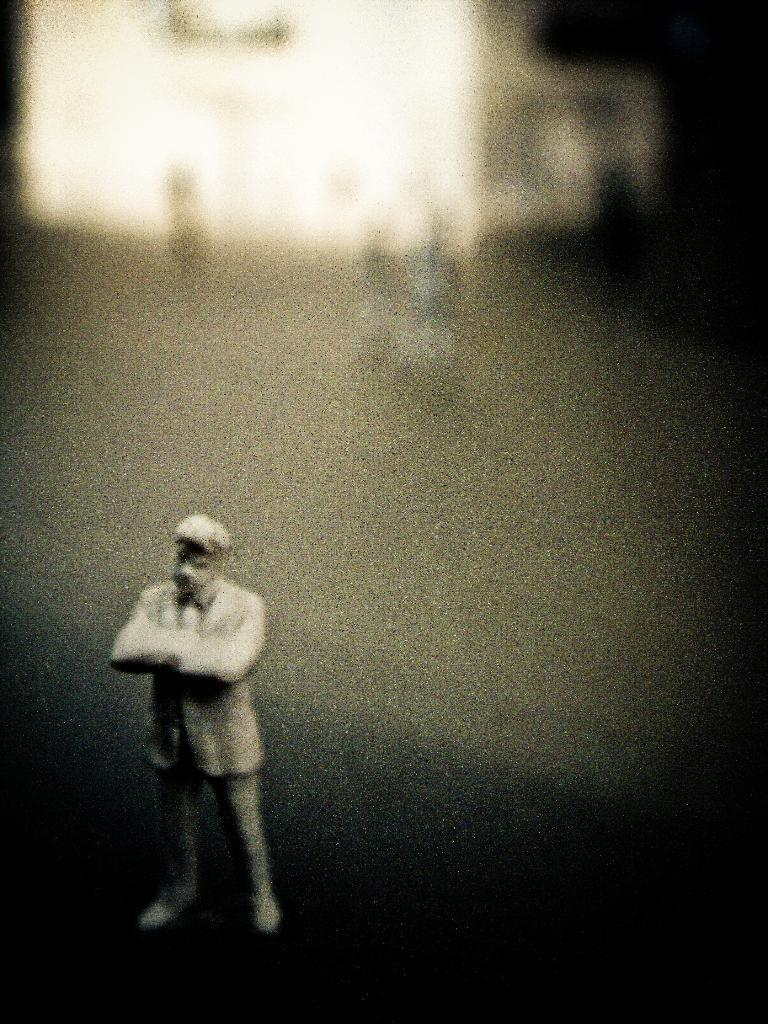What is the main subject of the image? There is a statue of a person standing in the image. Can you describe the statue in more detail? Unfortunately, the provided facts do not give any additional details about the statue. What else can be seen in the image besides the statue? There are other objects visible in the background of the image. What type of tail can be seen on the statue in the image? There is no tail present on the statue in the image. How many holes are visible in the statue in the image? There is no mention of holes in the statue in the image. 